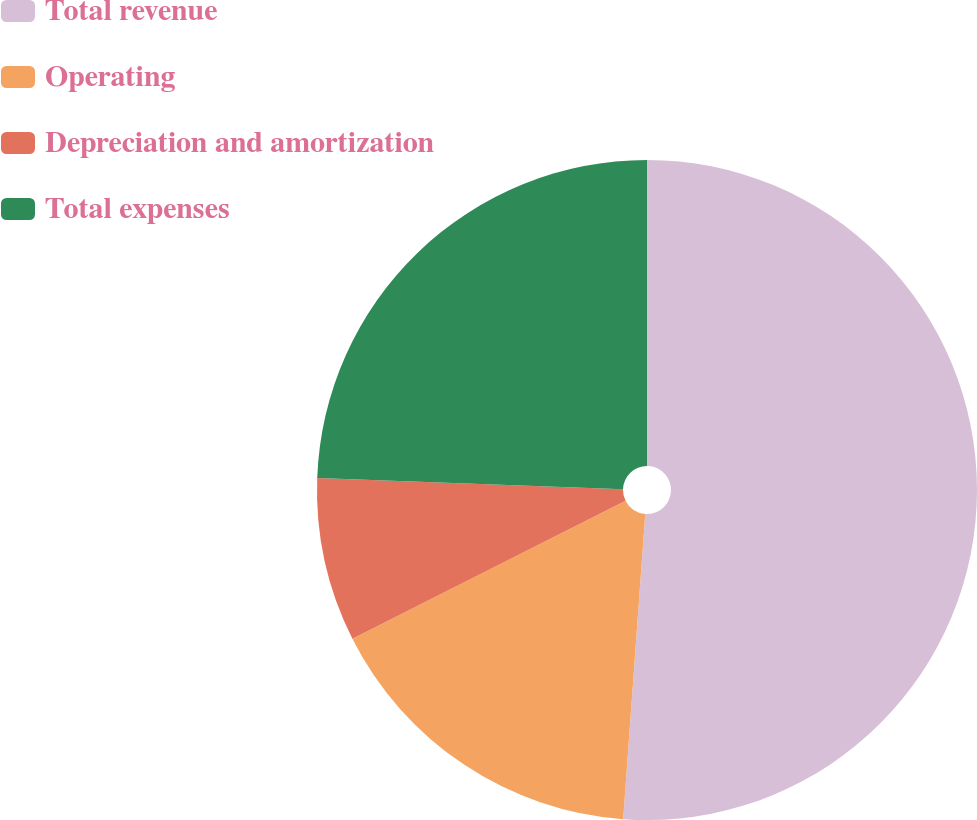Convert chart to OTSL. <chart><loc_0><loc_0><loc_500><loc_500><pie_chart><fcel>Total revenue<fcel>Operating<fcel>Depreciation and amortization<fcel>Total expenses<nl><fcel>51.15%<fcel>16.41%<fcel>8.02%<fcel>24.42%<nl></chart> 